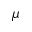Convert formula to latex. <formula><loc_0><loc_0><loc_500><loc_500>\mu</formula> 